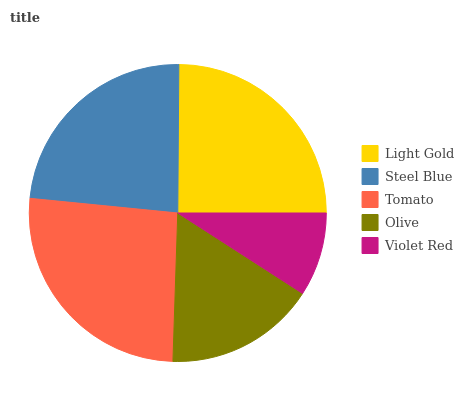Is Violet Red the minimum?
Answer yes or no. Yes. Is Tomato the maximum?
Answer yes or no. Yes. Is Steel Blue the minimum?
Answer yes or no. No. Is Steel Blue the maximum?
Answer yes or no. No. Is Light Gold greater than Steel Blue?
Answer yes or no. Yes. Is Steel Blue less than Light Gold?
Answer yes or no. Yes. Is Steel Blue greater than Light Gold?
Answer yes or no. No. Is Light Gold less than Steel Blue?
Answer yes or no. No. Is Steel Blue the high median?
Answer yes or no. Yes. Is Steel Blue the low median?
Answer yes or no. Yes. Is Violet Red the high median?
Answer yes or no. No. Is Light Gold the low median?
Answer yes or no. No. 